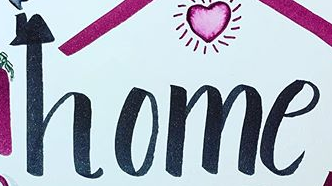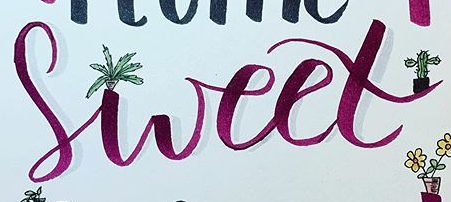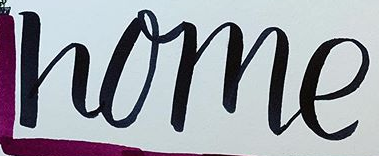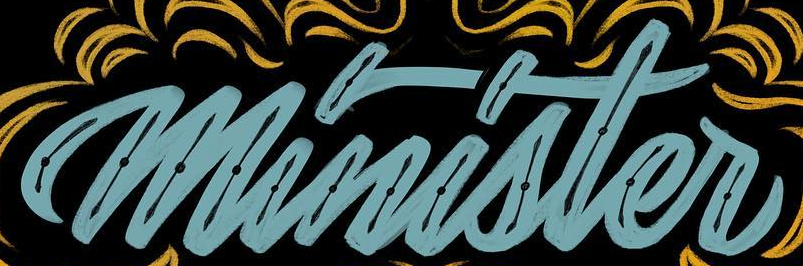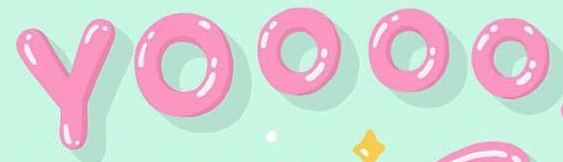Read the text content from these images in order, separated by a semicolon. home; sweet; home; minister; YOOOO 